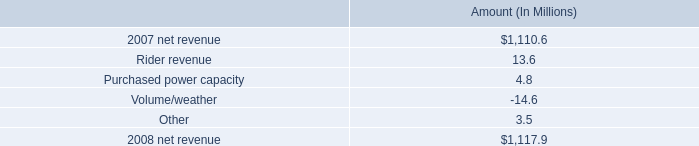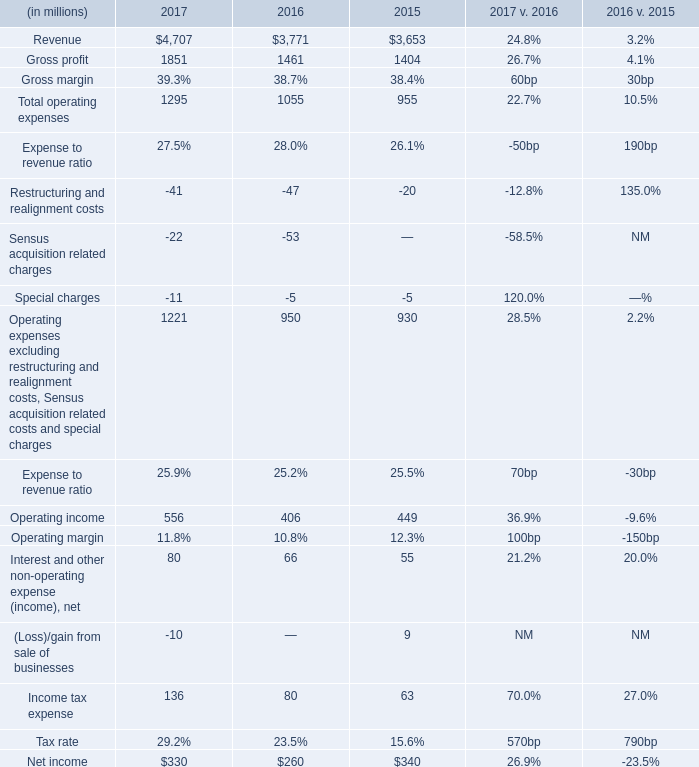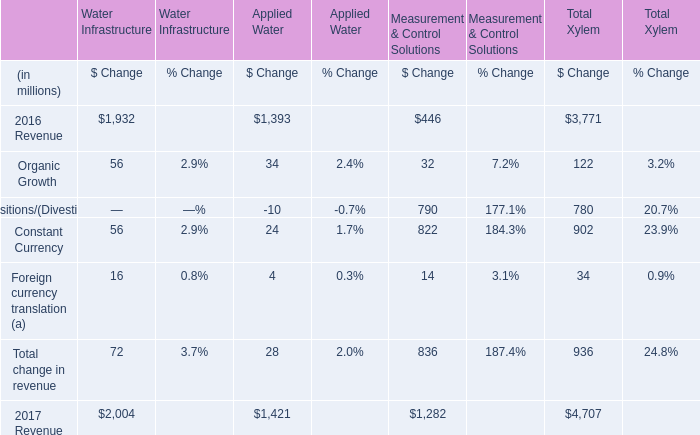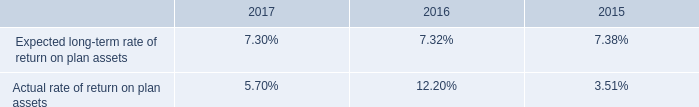As As the chart 2 shows,what is the value of Total change in revenue for Applied Water? (in million) 
Answer: 28. 